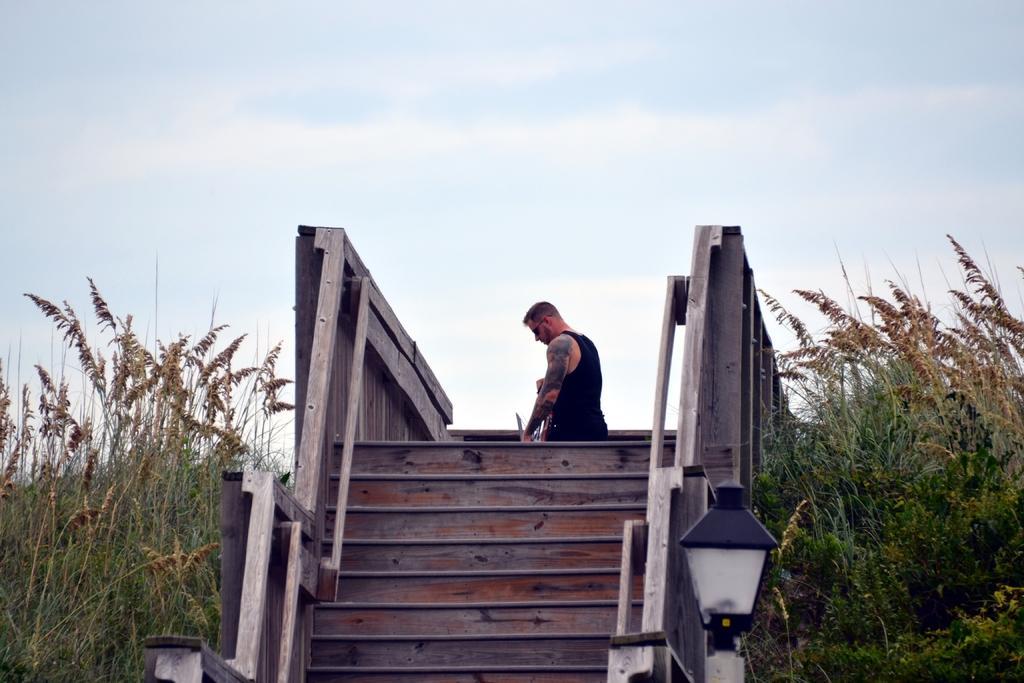How would you summarize this image in a sentence or two? There are steps with railings. One person is standing on that. On the sides there are plants. In the background there is sky. Near to the step there is a light. 